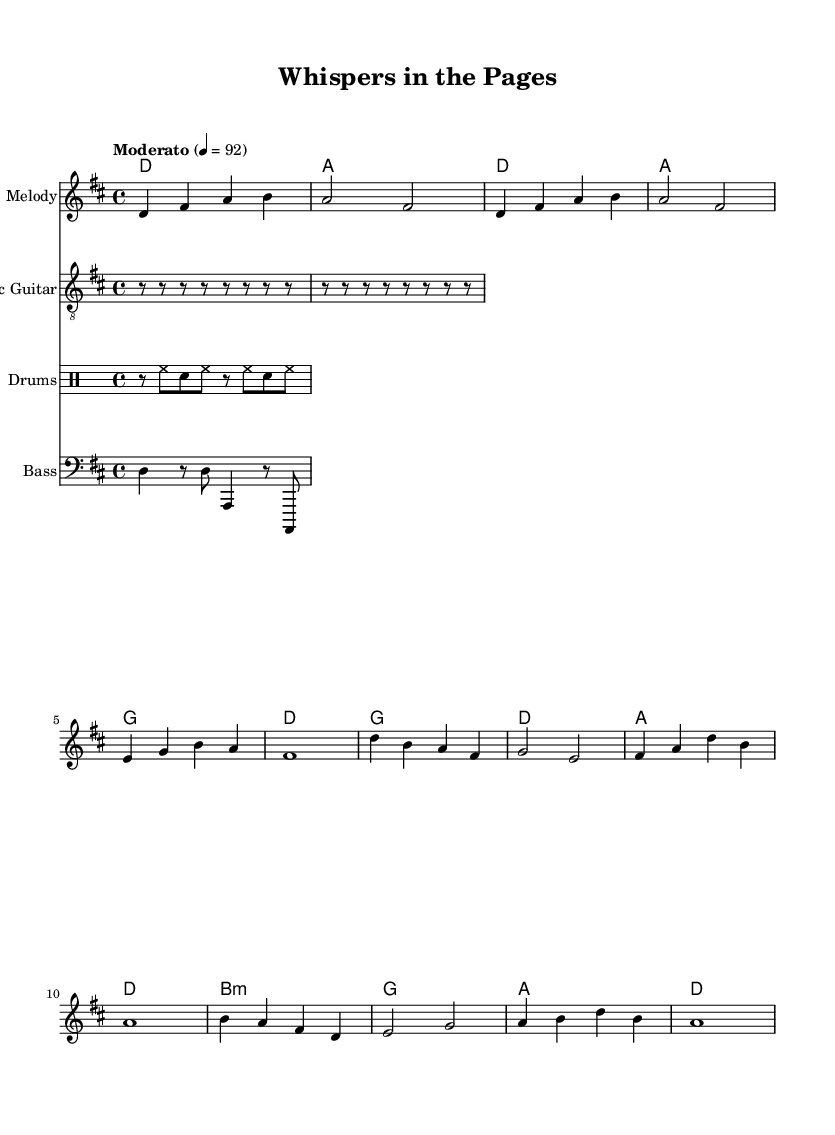What is the key signature of this music? The key signature is D major, which contains two sharps: F-sharp and C-sharp. This can be identified at the beginning of the music staff where the sharps are indicated.
Answer: D major What is the time signature of this piece? The time signature is 4/4, which means there are four beats in each measure and a quarter note gets one beat. This is indicated as a fraction at the beginning of the score.
Answer: 4/4 What is the tempo marking for this piece? The tempo marking is "Moderato," which suggests a moderate pace, typically around 92 beats per minute. This is also indicated near the beginning of the score.
Answer: Moderato How many verses are in the lyrics? There are two verses in the lyrics, as indicated by the structure of the lyric mode in the score presentation, separated from the chorus.
Answer: Two What chords are used in the chorus section? The chords in the chorus section are G, D, A, and D, each corresponding to the phrases sung in that part, as shown in the chord section of the score.
Answer: G, D, A, D What type of instrumental accompaniment is suggested by the sheet music? The sheet music includes an acoustic guitar part, along with bass and drums, indicating a typical indie rock setup. This can be seen from the different staves labeled as "Acoustic Guitar," "Bass," and "Drums."
Answer: Acoustic guitar What is the primary theme reflected in the lyrics? The primary theme reflected in the lyrics is introspection and finding peace within the pages of a book, as expressed in phrases about words dancing and whispers in the pages. This can be inferred from the content of the verse and chorus lyrics.
Answer: Introspection 